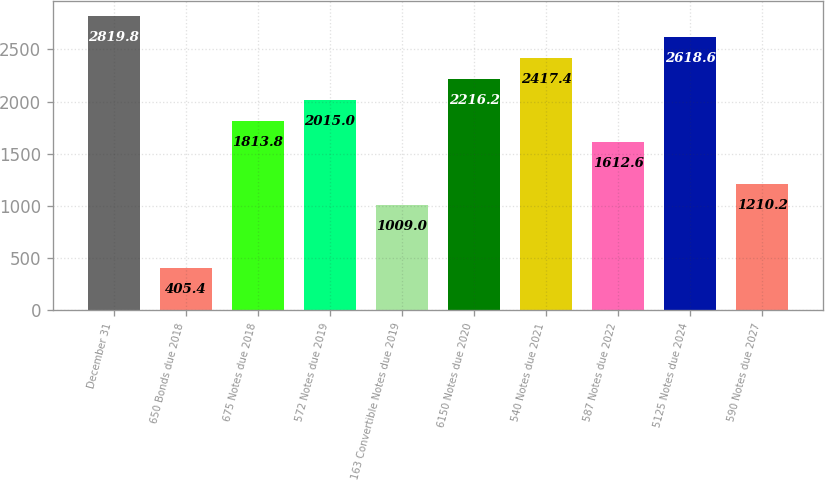Convert chart. <chart><loc_0><loc_0><loc_500><loc_500><bar_chart><fcel>December 31<fcel>650 Bonds due 2018<fcel>675 Notes due 2018<fcel>572 Notes due 2019<fcel>163 Convertible Notes due 2019<fcel>6150 Notes due 2020<fcel>540 Notes due 2021<fcel>587 Notes due 2022<fcel>5125 Notes due 2024<fcel>590 Notes due 2027<nl><fcel>2819.8<fcel>405.4<fcel>1813.8<fcel>2015<fcel>1009<fcel>2216.2<fcel>2417.4<fcel>1612.6<fcel>2618.6<fcel>1210.2<nl></chart> 